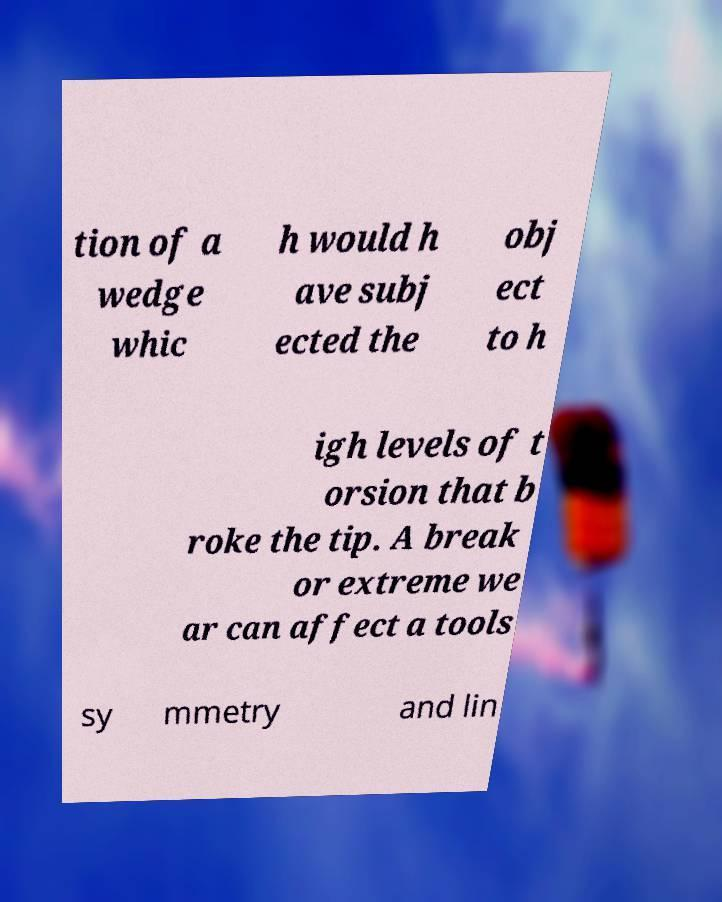Please read and relay the text visible in this image. What does it say? tion of a wedge whic h would h ave subj ected the obj ect to h igh levels of t orsion that b roke the tip. A break or extreme we ar can affect a tools sy mmetry and lin 